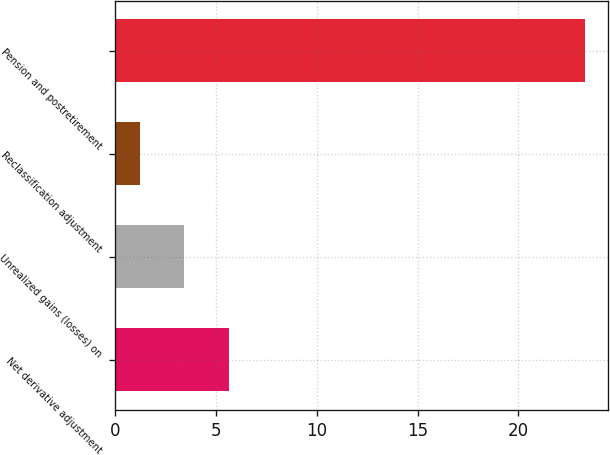Convert chart. <chart><loc_0><loc_0><loc_500><loc_500><bar_chart><fcel>Net derivative adjustment<fcel>Unrealized gains (losses) on<fcel>Reclassification adjustment<fcel>Pension and postretirement<nl><fcel>5.62<fcel>3.41<fcel>1.2<fcel>23.3<nl></chart> 